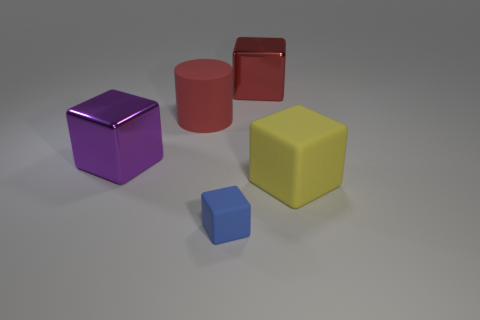Subtract 1 blocks. How many blocks are left? 3 Add 3 cylinders. How many objects exist? 8 Subtract all cylinders. How many objects are left? 4 Subtract 0 green cylinders. How many objects are left? 5 Subtract all large objects. Subtract all large cyan rubber spheres. How many objects are left? 1 Add 5 large cubes. How many large cubes are left? 8 Add 2 brown metallic blocks. How many brown metallic blocks exist? 2 